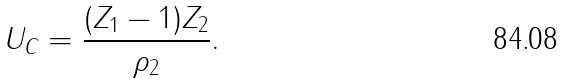<formula> <loc_0><loc_0><loc_500><loc_500>U _ { C } = \frac { ( Z _ { 1 } - 1 ) Z _ { 2 } } { \rho _ { 2 } } .</formula> 